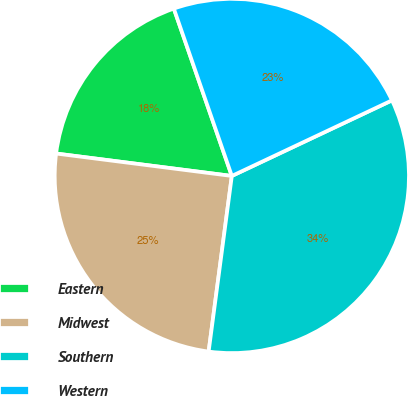<chart> <loc_0><loc_0><loc_500><loc_500><pie_chart><fcel>Eastern<fcel>Midwest<fcel>Southern<fcel>Western<nl><fcel>17.67%<fcel>24.93%<fcel>34.11%<fcel>23.29%<nl></chart> 